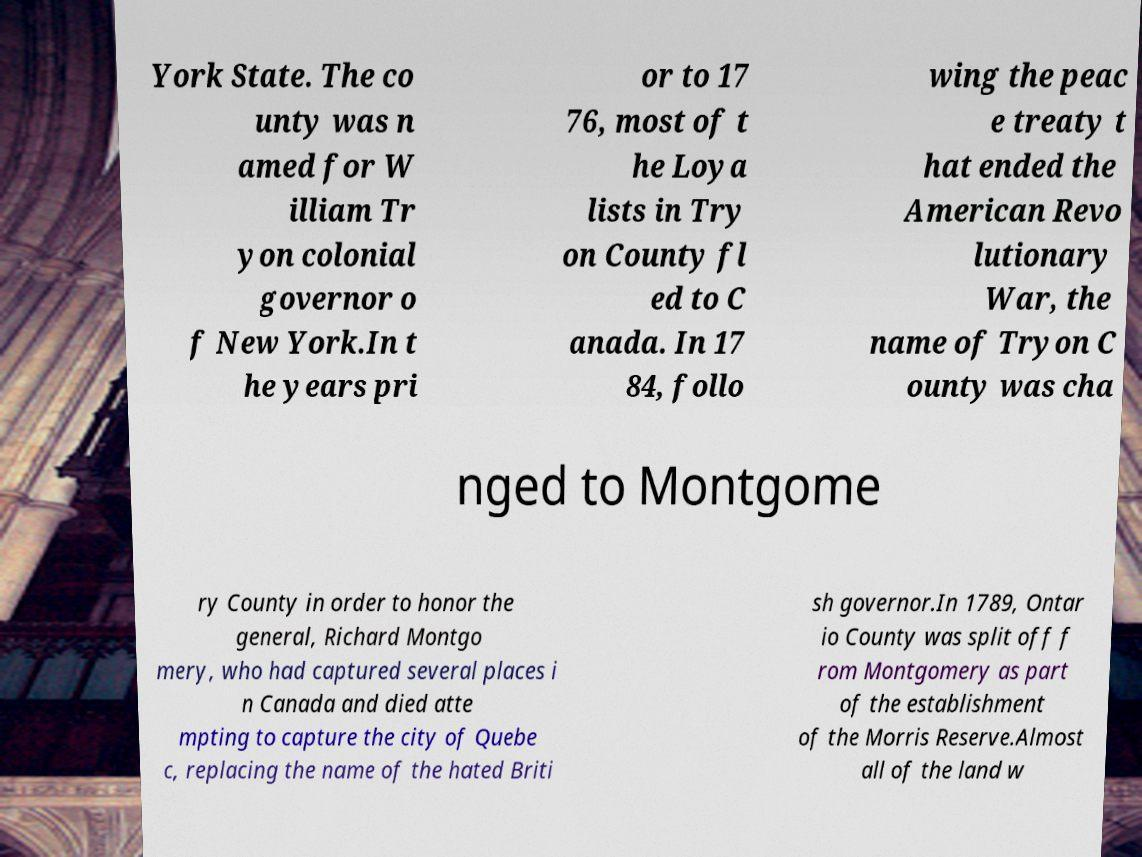For documentation purposes, I need the text within this image transcribed. Could you provide that? York State. The co unty was n amed for W illiam Tr yon colonial governor o f New York.In t he years pri or to 17 76, most of t he Loya lists in Try on County fl ed to C anada. In 17 84, follo wing the peac e treaty t hat ended the American Revo lutionary War, the name of Tryon C ounty was cha nged to Montgome ry County in order to honor the general, Richard Montgo mery, who had captured several places i n Canada and died atte mpting to capture the city of Quebe c, replacing the name of the hated Briti sh governor.In 1789, Ontar io County was split off f rom Montgomery as part of the establishment of the Morris Reserve.Almost all of the land w 